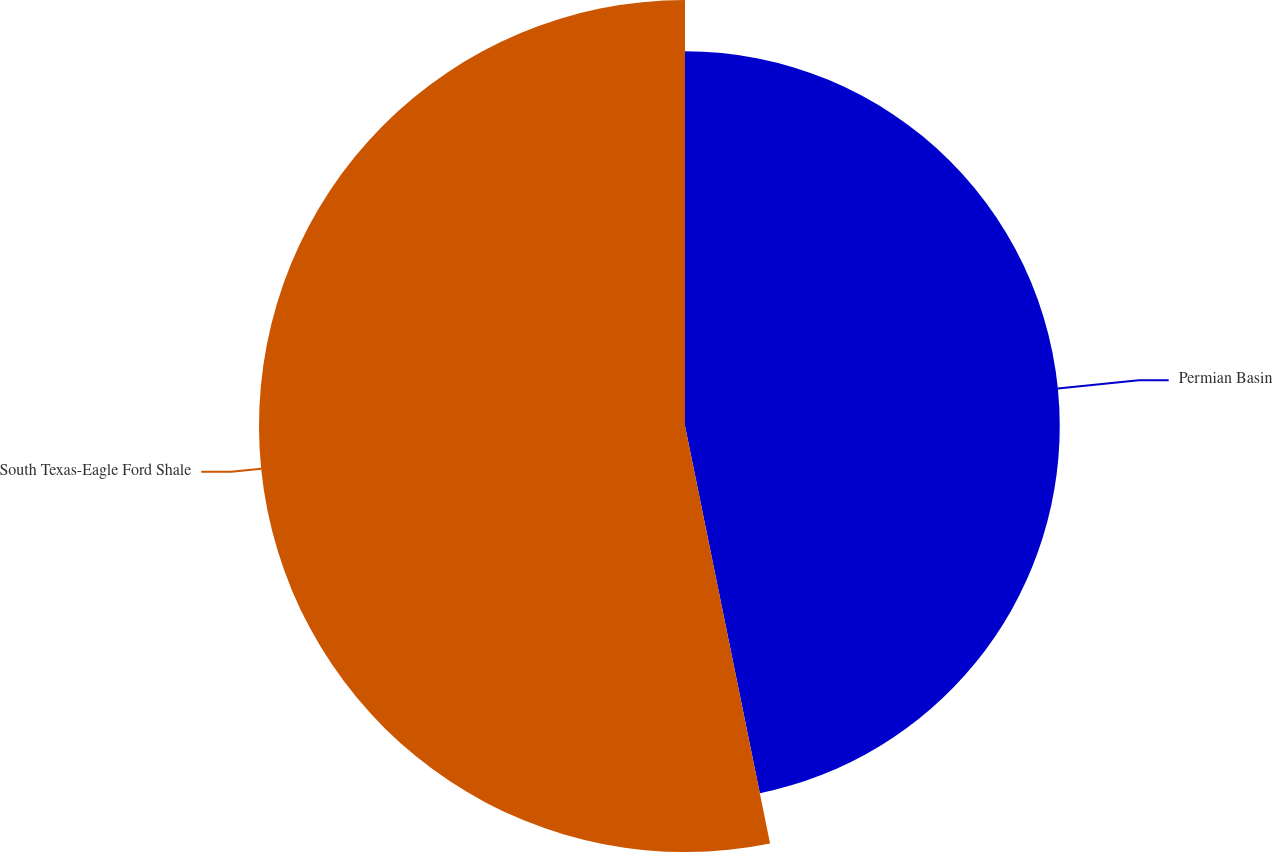Convert chart. <chart><loc_0><loc_0><loc_500><loc_500><pie_chart><fcel>Permian Basin<fcel>South Texas-Eagle Ford Shale<nl><fcel>46.8%<fcel>53.2%<nl></chart> 